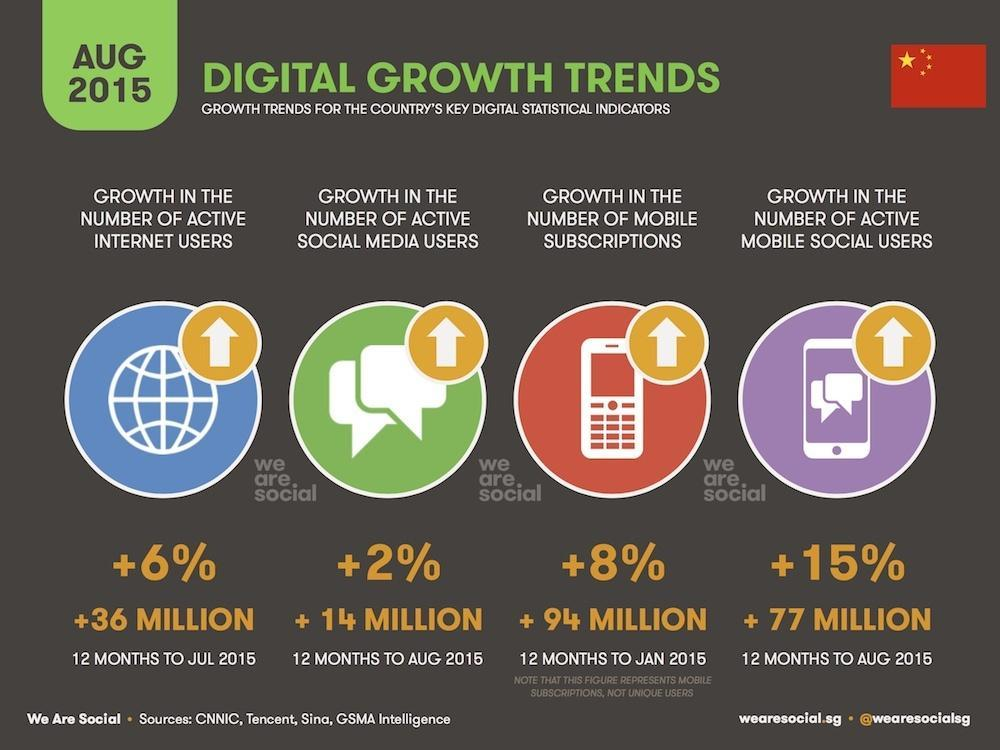By how much did the number of mobile subscriptions increase?
Answer the question with a short phrase. 94 million What is the percentage increase in number of active internet users? 6% What increased by 77 million by Aug 2015? number of active mobile social users By what percentage did number of social media users grow? 2% 